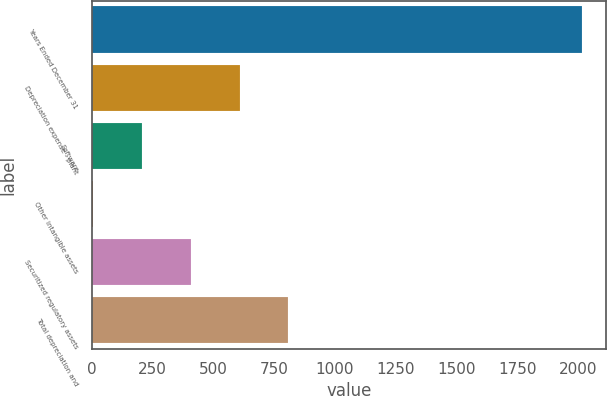<chart> <loc_0><loc_0><loc_500><loc_500><bar_chart><fcel>Years Ended December 31<fcel>Depreciation expense - plant<fcel>Software<fcel>Other intangible assets<fcel>Securitized regulatory assets<fcel>Total depreciation and<nl><fcel>2015<fcel>607.3<fcel>205.1<fcel>4<fcel>406.2<fcel>808.4<nl></chart> 